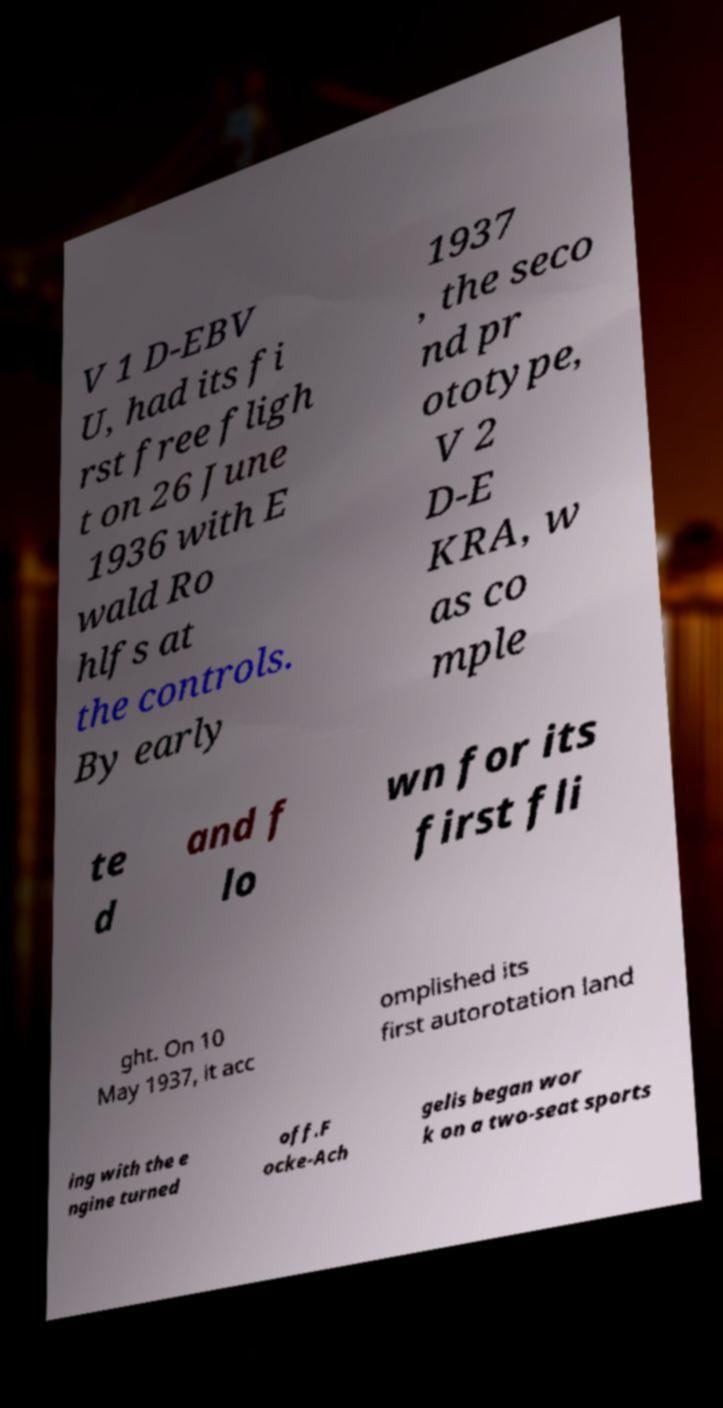Can you read and provide the text displayed in the image?This photo seems to have some interesting text. Can you extract and type it out for me? V 1 D-EBV U, had its fi rst free fligh t on 26 June 1936 with E wald Ro hlfs at the controls. By early 1937 , the seco nd pr ototype, V 2 D-E KRA, w as co mple te d and f lo wn for its first fli ght. On 10 May 1937, it acc omplished its first autorotation land ing with the e ngine turned off.F ocke-Ach gelis began wor k on a two-seat sports 